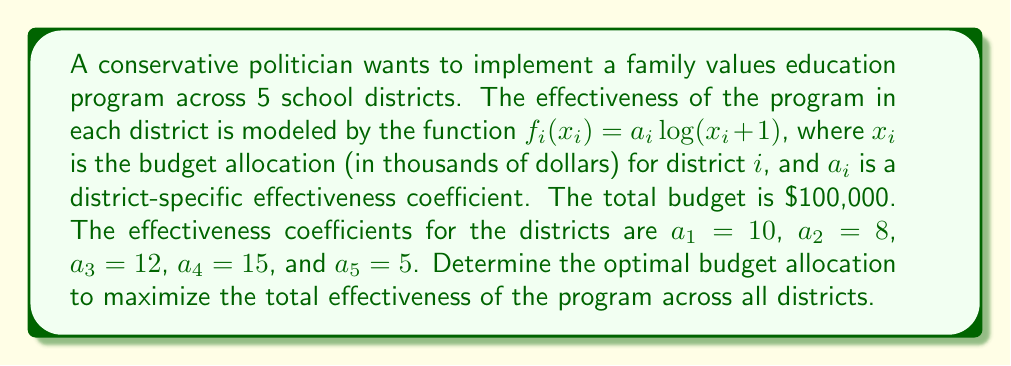Provide a solution to this math problem. To solve this optimization problem, we can use the method of Lagrange multipliers. Let's follow these steps:

1) The objective function to maximize is:
   $$f(x_1, x_2, x_3, x_4, x_5) = 10\log(x_1 + 1) + 8\log(x_2 + 1) + 12\log(x_3 + 1) + 15\log(x_4 + 1) + 5\log(x_5 + 1)$$

2) The constraint is:
   $$x_1 + x_2 + x_3 + x_4 + x_5 = 100$$

3) We form the Lagrangian:
   $$L = f(x_1, x_2, x_3, x_4, x_5) - \lambda(x_1 + x_2 + x_3 + x_4 + x_5 - 100)$$

4) We take partial derivatives and set them to zero:
   $$\frac{\partial L}{\partial x_1} = \frac{10}{x_1 + 1} - \lambda = 0$$
   $$\frac{\partial L}{\partial x_2} = \frac{8}{x_2 + 1} - \lambda = 0$$
   $$\frac{\partial L}{\partial x_3} = \frac{12}{x_3 + 1} - \lambda = 0$$
   $$\frac{\partial L}{\partial x_4} = \frac{15}{x_4 + 1} - \lambda = 0$$
   $$\frac{\partial L}{\partial x_5} = \frac{5}{x_5 + 1} - \lambda = 0$$

5) From these equations, we can deduce:
   $$x_1 + 1 = \frac{10}{\lambda}, x_2 + 1 = \frac{8}{\lambda}, x_3 + 1 = \frac{12}{\lambda}, x_4 + 1 = \frac{15}{\lambda}, x_5 + 1 = \frac{5}{\lambda}$$

6) Substituting these into the constraint equation:
   $$(\frac{10}{\lambda} - 1) + (\frac{8}{\lambda} - 1) + (\frac{12}{\lambda} - 1) + (\frac{15}{\lambda} - 1) + (\frac{5}{\lambda} - 1) = 100$$

7) Simplifying:
   $$\frac{50}{\lambda} - 5 = 100$$
   $$\frac{50}{\lambda} = 105$$
   $$\lambda = \frac{50}{105} = \frac{10}{21}$$

8) Now we can solve for each $x_i$:
   $$x_1 = \frac{10}{\lambda} - 1 = \frac{10}{\frac{10}{21}} - 1 = 21 - 1 = 20$$
   $$x_2 = \frac{8}{\lambda} - 1 = \frac{8}{\frac{10}{21}} - 1 = 16.8 - 1 = 15.8$$
   $$x_3 = \frac{12}{\lambda} - 1 = \frac{12}{\frac{10}{21}} - 1 = 25.2 - 1 = 24.2$$
   $$x_4 = \frac{15}{\lambda} - 1 = \frac{15}{\frac{10}{21}} - 1 = 31.5 - 1 = 30.5$$
   $$x_5 = \frac{5}{\lambda} - 1 = \frac{5}{\frac{10}{21}} - 1 = 10.5 - 1 = 9.5$$

These values sum to 100, confirming our solution.
Answer: The optimal budget allocation (in thousands of dollars) is:
District 1: $20
District 2: $15.8
District 3: $24.2
District 4: $30.5
District 5: $9.5 